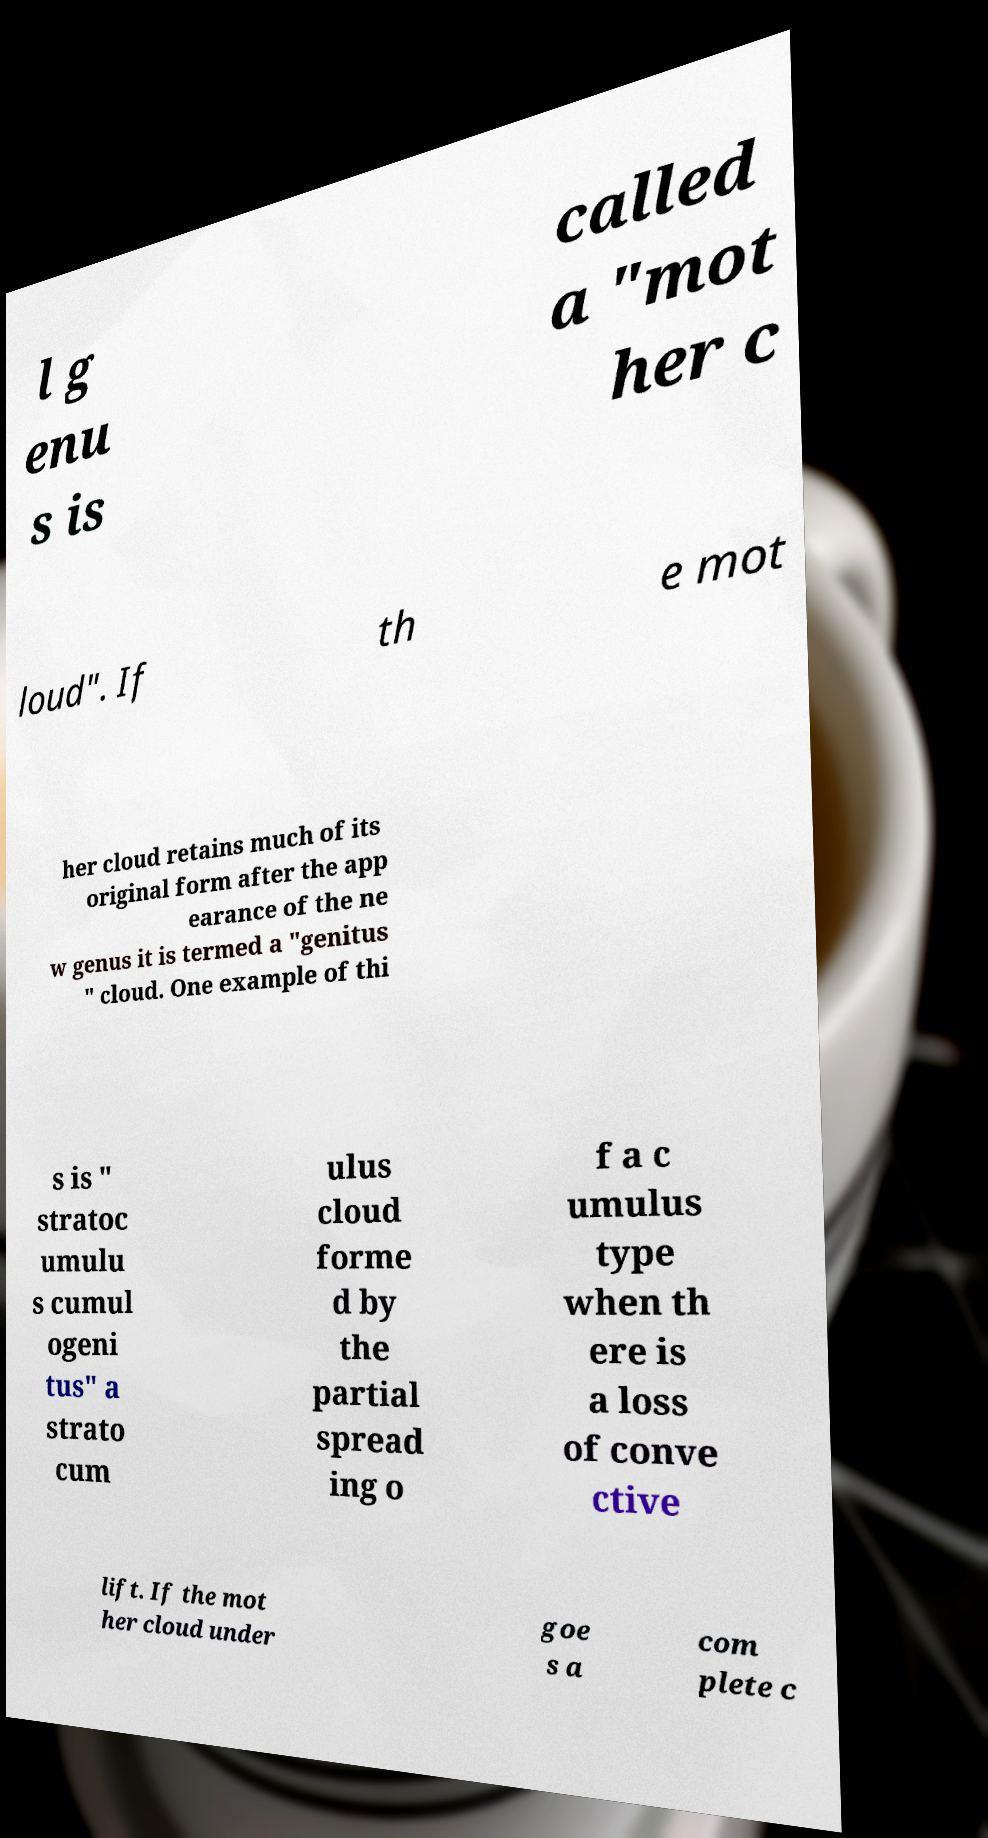There's text embedded in this image that I need extracted. Can you transcribe it verbatim? l g enu s is called a "mot her c loud". If th e mot her cloud retains much of its original form after the app earance of the ne w genus it is termed a "genitus " cloud. One example of thi s is " stratoc umulu s cumul ogeni tus" a strato cum ulus cloud forme d by the partial spread ing o f a c umulus type when th ere is a loss of conve ctive lift. If the mot her cloud under goe s a com plete c 